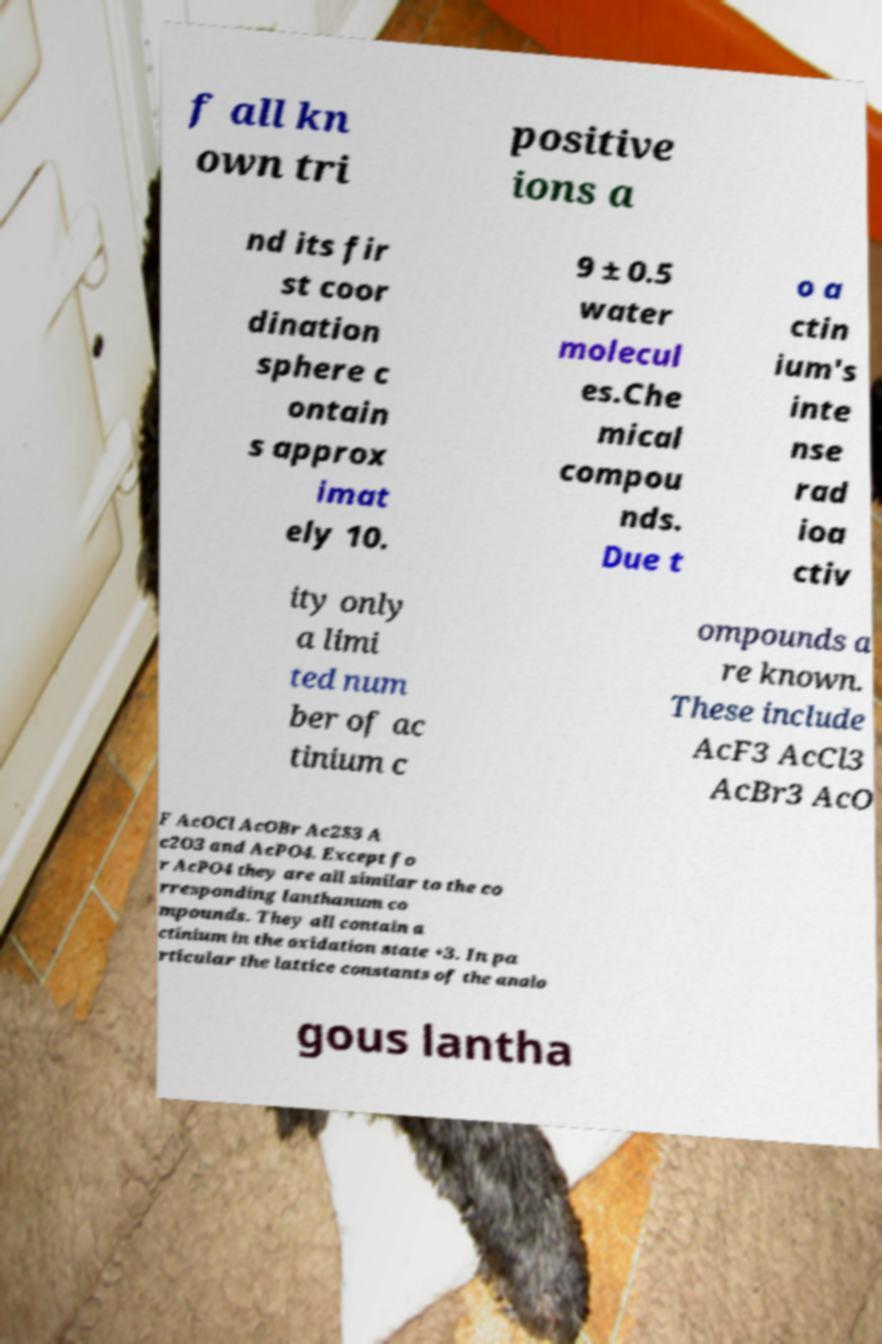Could you assist in decoding the text presented in this image and type it out clearly? f all kn own tri positive ions a nd its fir st coor dination sphere c ontain s approx imat ely 10. 9 ± 0.5 water molecul es.Che mical compou nds. Due t o a ctin ium's inte nse rad ioa ctiv ity only a limi ted num ber of ac tinium c ompounds a re known. These include AcF3 AcCl3 AcBr3 AcO F AcOCl AcOBr Ac2S3 A c2O3 and AcPO4. Except fo r AcPO4 they are all similar to the co rresponding lanthanum co mpounds. They all contain a ctinium in the oxidation state +3. In pa rticular the lattice constants of the analo gous lantha 